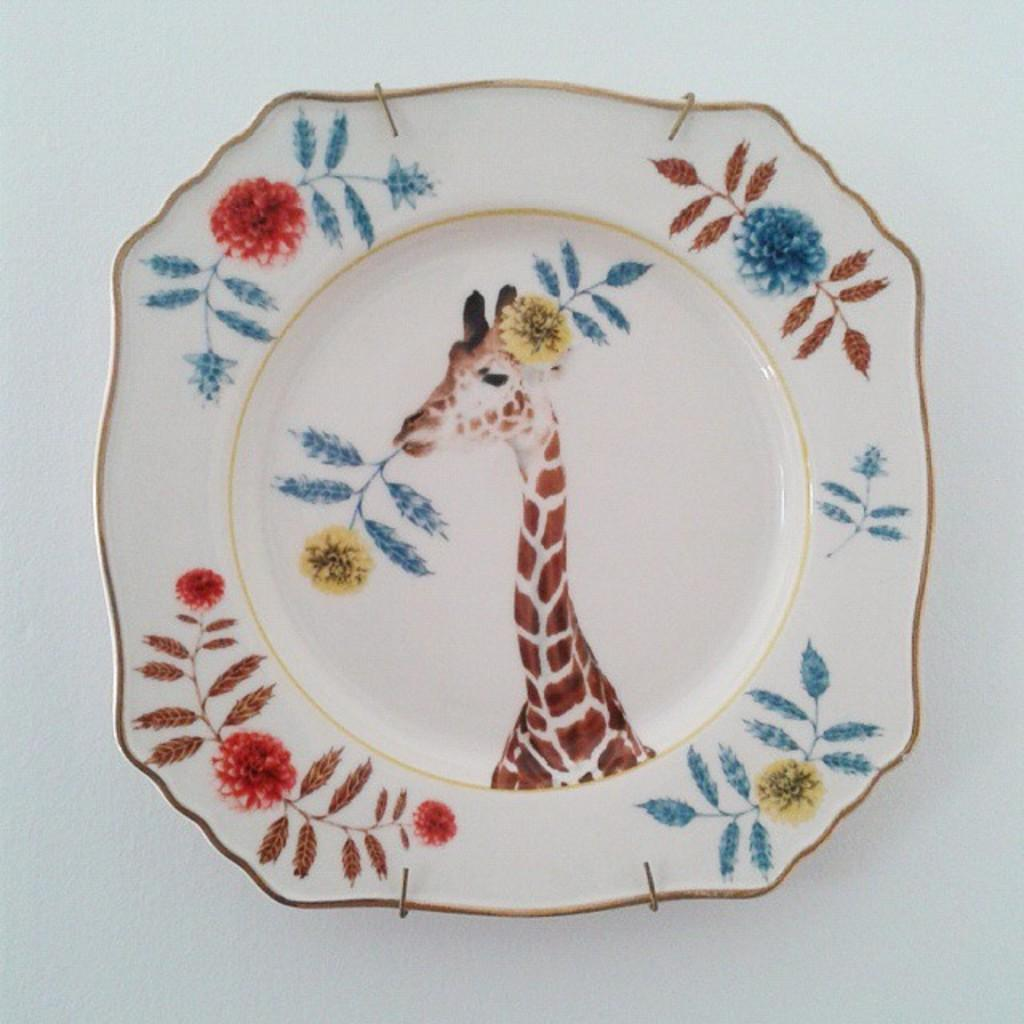What is present on the plate in the image? There is a giraffe on the plate in the image. What colors are used to depict the giraffe? The giraffe is white and brown. What is the color of the plate? The plate is white. What is the background color of the image? The background of the image is white. Can you see a baby wearing a cap in the image? There is no baby or cap present in the image; it features a white plate with a white background and a white and brown giraffe on it. Are there any bricks visible in the image? There are no bricks present in the image. 